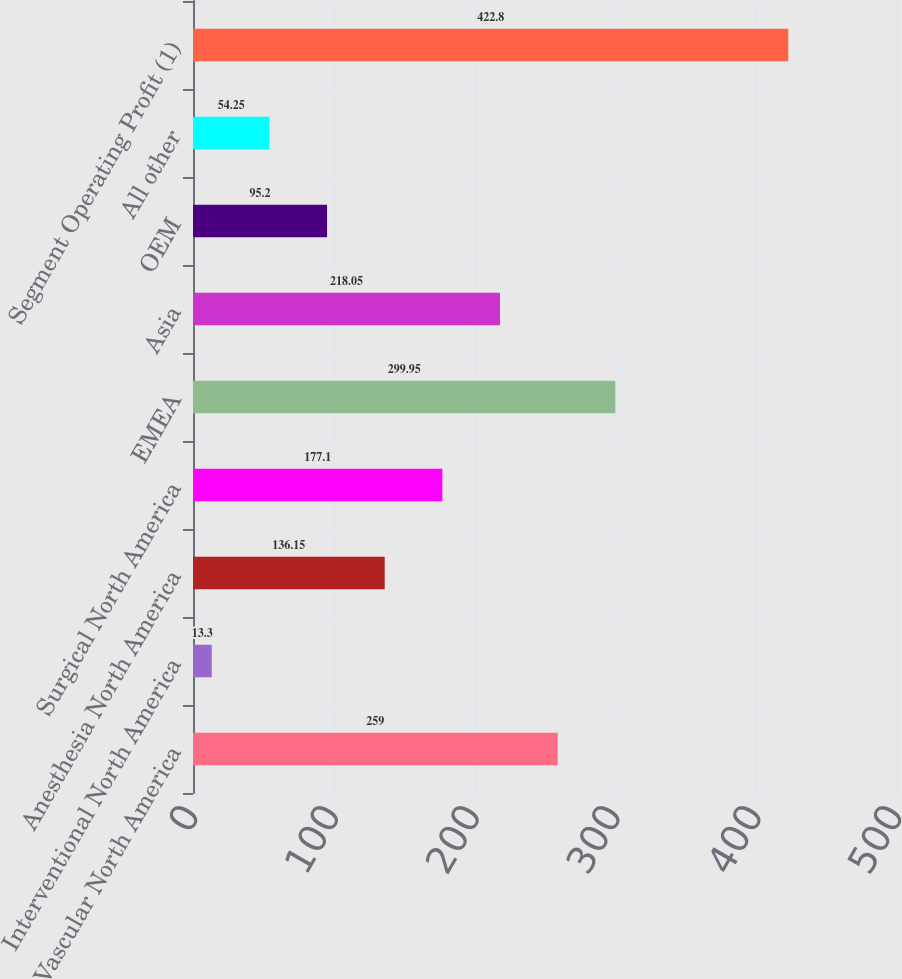Convert chart to OTSL. <chart><loc_0><loc_0><loc_500><loc_500><bar_chart><fcel>Vascular North America<fcel>Interventional North America<fcel>Anesthesia North America<fcel>Surgical North America<fcel>EMEA<fcel>Asia<fcel>OEM<fcel>All other<fcel>Segment Operating Profit (1)<nl><fcel>259<fcel>13.3<fcel>136.15<fcel>177.1<fcel>299.95<fcel>218.05<fcel>95.2<fcel>54.25<fcel>422.8<nl></chart> 